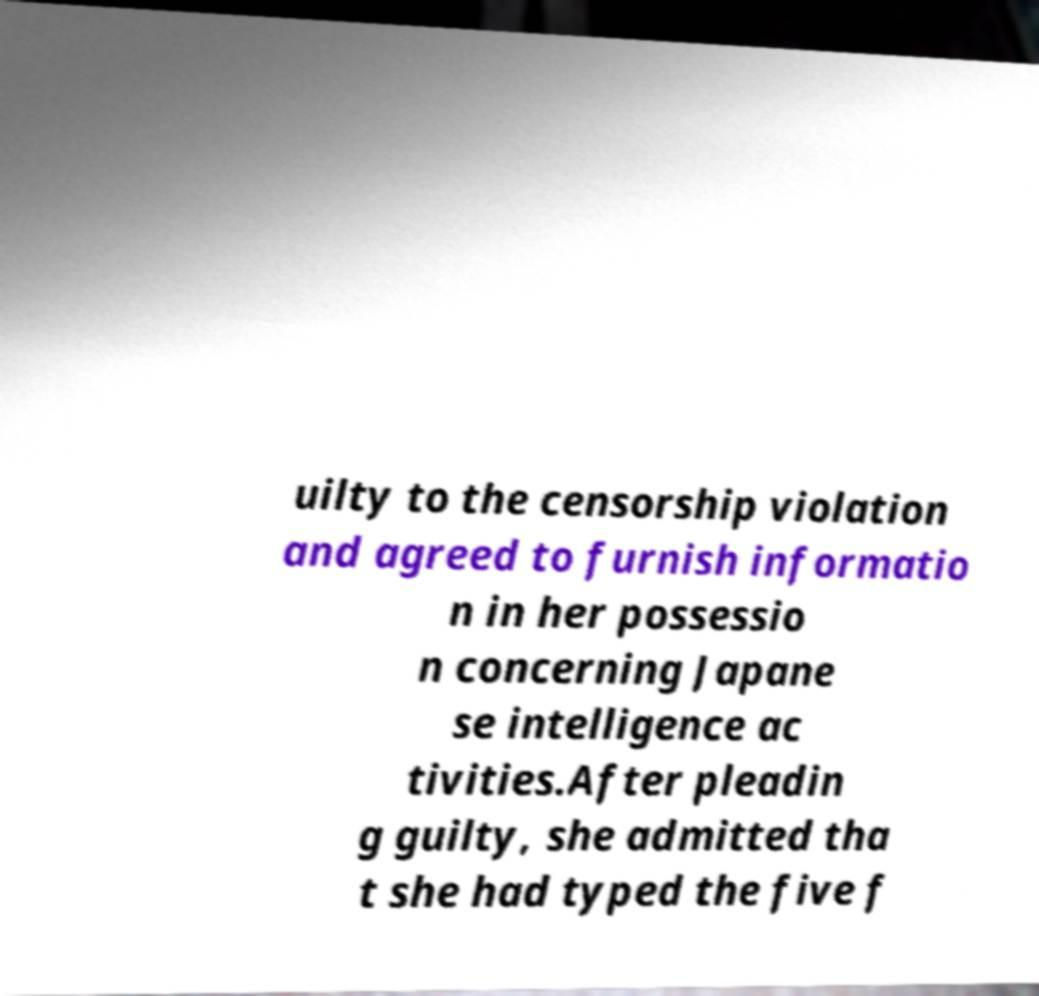What messages or text are displayed in this image? I need them in a readable, typed format. uilty to the censorship violation and agreed to furnish informatio n in her possessio n concerning Japane se intelligence ac tivities.After pleadin g guilty, she admitted tha t she had typed the five f 